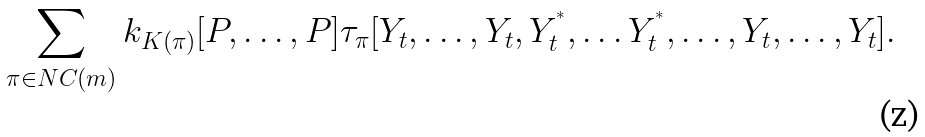Convert formula to latex. <formula><loc_0><loc_0><loc_500><loc_500>\sum _ { \pi \in N C ( m ) } k _ { K ( \pi ) } [ P , \dots , P ] \tau _ { \pi } [ Y _ { t } , \dots , Y _ { t } , Y _ { t } ^ { ^ { * } } , \dots Y _ { t } ^ { ^ { * } } , \dots , Y _ { t } , \dots , Y _ { t } ] .</formula> 